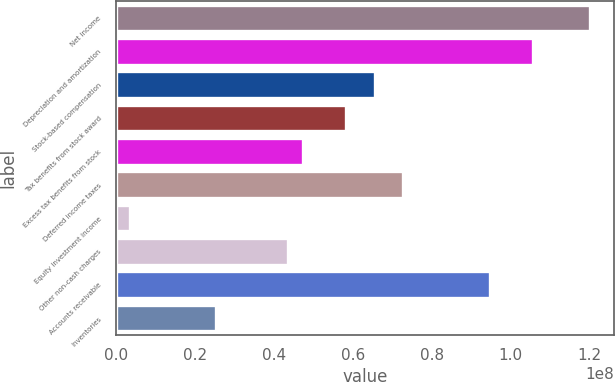Convert chart. <chart><loc_0><loc_0><loc_500><loc_500><bar_chart><fcel>Net income<fcel>Depreciation and amortization<fcel>Stock-based compensation<fcel>Tax benefits from stock award<fcel>Excess tax benefits from stock<fcel>Deferred income taxes<fcel>Equity investment income<fcel>Other non-cash charges<fcel>Accounts receivable<fcel>Inventories<nl><fcel>1.20103e+08<fcel>1.05545e+08<fcel>6.55109e+07<fcel>5.8232e+07<fcel>4.73135e+07<fcel>7.27899e+07<fcel>3.63982e+06<fcel>4.36741e+07<fcel>9.46267e+07<fcel>2.54767e+07<nl></chart> 